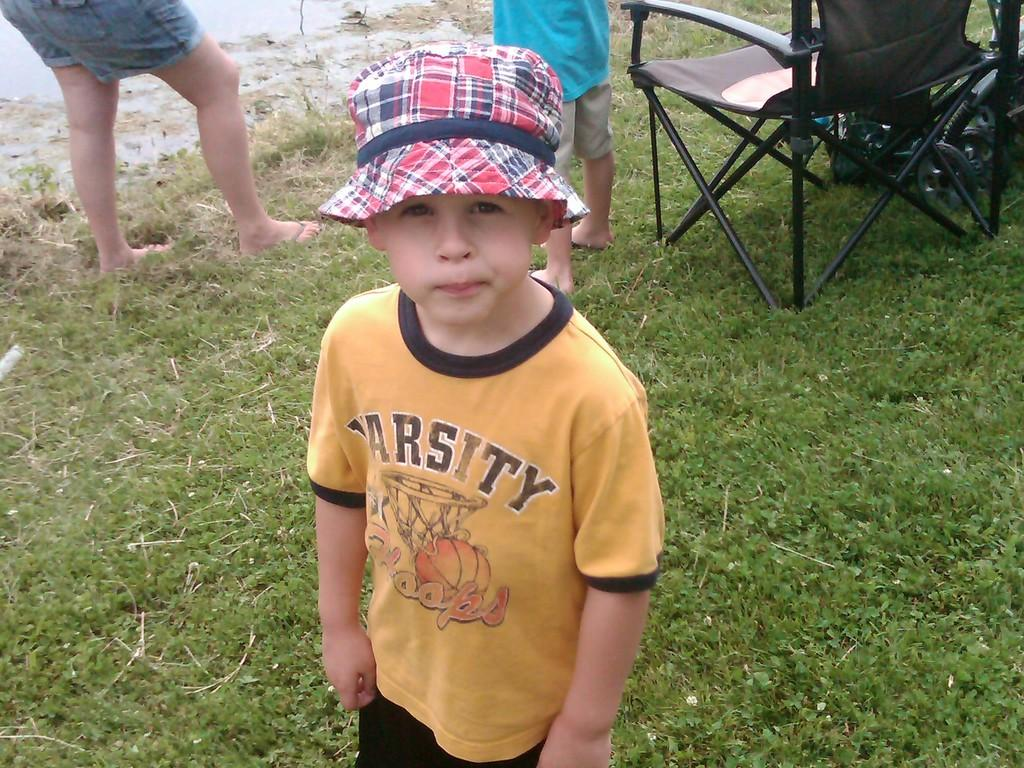Who is the main subject in the image? There is a boy in the image. What is the boy wearing on his head? The boy is wearing a cap. Where is the boy standing? The boy is standing on grass. What can be seen in the background of the image? There is a chair and two persons in the background of the image. What type of sand can be seen on the boy's shoes in the image? There is no sand visible in the image, and the boy's shoes are not mentioned. 